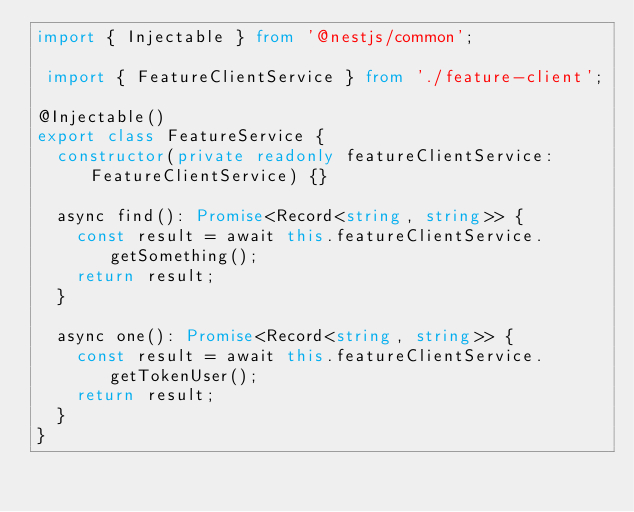<code> <loc_0><loc_0><loc_500><loc_500><_TypeScript_>import { Injectable } from '@nestjs/common';

 import { FeatureClientService } from './feature-client';

@Injectable()
export class FeatureService {
  constructor(private readonly featureClientService: FeatureClientService) {}

  async find(): Promise<Record<string, string>> {
    const result = await this.featureClientService.getSomething();
    return result;
  }

  async one(): Promise<Record<string, string>> {
    const result = await this.featureClientService.getTokenUser();
    return result;
  }
}
</code> 